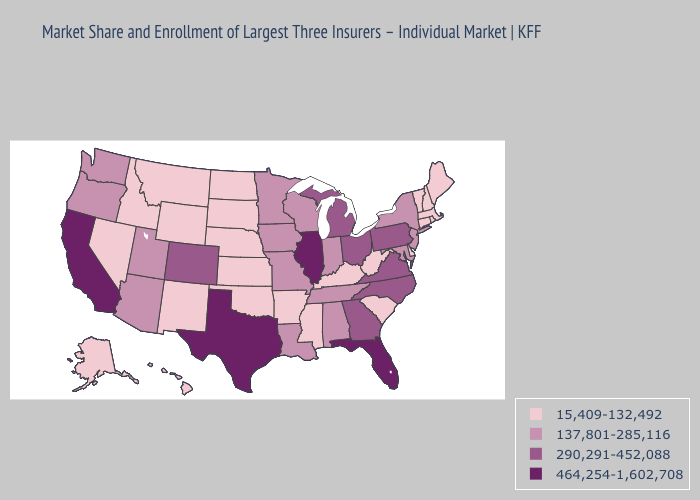Does Utah have the lowest value in the USA?
Answer briefly. No. Does Missouri have the lowest value in the USA?
Give a very brief answer. No. Name the states that have a value in the range 290,291-452,088?
Answer briefly. Colorado, Georgia, Michigan, North Carolina, Ohio, Pennsylvania, Virginia. Does the map have missing data?
Quick response, please. No. Name the states that have a value in the range 290,291-452,088?
Concise answer only. Colorado, Georgia, Michigan, North Carolina, Ohio, Pennsylvania, Virginia. What is the highest value in the West ?
Quick response, please. 464,254-1,602,708. What is the value of Utah?
Write a very short answer. 137,801-285,116. What is the lowest value in states that border Wyoming?
Short answer required. 15,409-132,492. Does Texas have the highest value in the USA?
Give a very brief answer. Yes. Among the states that border Massachusetts , which have the highest value?
Keep it brief. New York. What is the value of Rhode Island?
Quick response, please. 15,409-132,492. Does Alabama have a lower value than Illinois?
Answer briefly. Yes. Among the states that border Michigan , does Indiana have the lowest value?
Write a very short answer. Yes. Does Nevada have the highest value in the USA?
Keep it brief. No. 